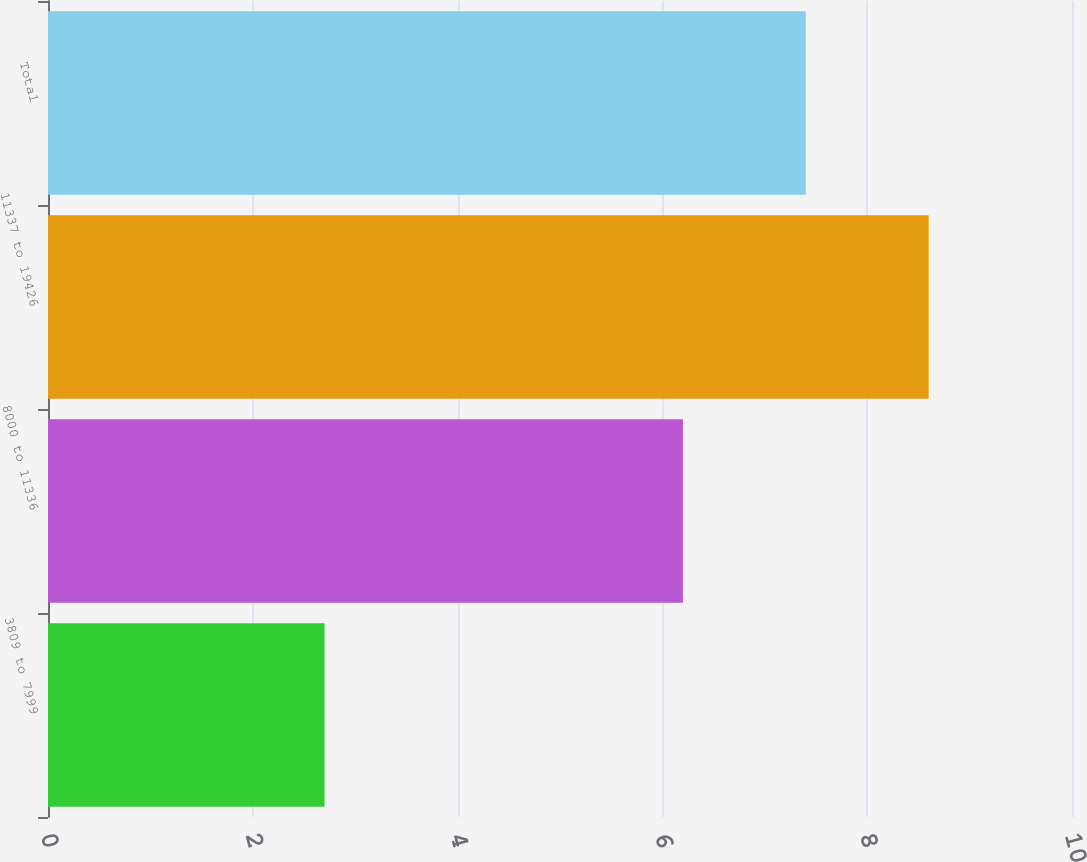<chart> <loc_0><loc_0><loc_500><loc_500><bar_chart><fcel>3809 to 7999<fcel>8000 to 11336<fcel>11337 to 19426<fcel>Total<nl><fcel>2.7<fcel>6.2<fcel>8.6<fcel>7.4<nl></chart> 